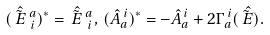Convert formula to latex. <formula><loc_0><loc_0><loc_500><loc_500>( \hat { \tilde { E } \, } \, ^ { a } _ { \, i } ) ^ { \ast } = \hat { \tilde { E } \, } \, ^ { a } _ { \, i } , \, ( \hat { A } _ { a } ^ { \, i } ) ^ { \ast } = - \hat { A } _ { a } ^ { \, i } + 2 \Gamma _ { a } ^ { \, i } ( \hat { \tilde { E } \, } ) .</formula> 